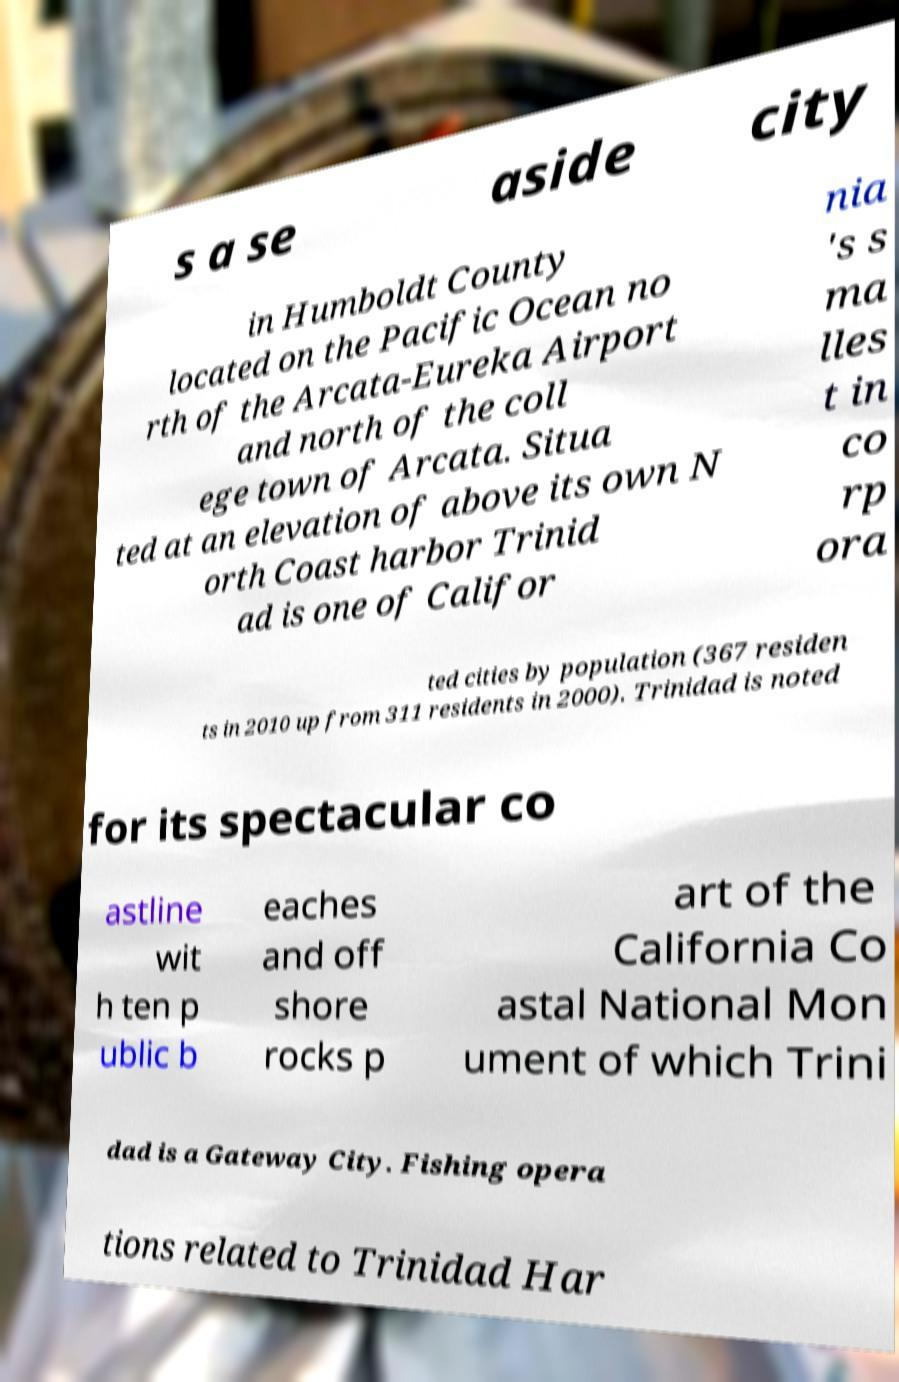Can you read and provide the text displayed in the image?This photo seems to have some interesting text. Can you extract and type it out for me? s a se aside city in Humboldt County located on the Pacific Ocean no rth of the Arcata-Eureka Airport and north of the coll ege town of Arcata. Situa ted at an elevation of above its own N orth Coast harbor Trinid ad is one of Califor nia 's s ma lles t in co rp ora ted cities by population (367 residen ts in 2010 up from 311 residents in 2000). Trinidad is noted for its spectacular co astline wit h ten p ublic b eaches and off shore rocks p art of the California Co astal National Mon ument of which Trini dad is a Gateway City. Fishing opera tions related to Trinidad Har 